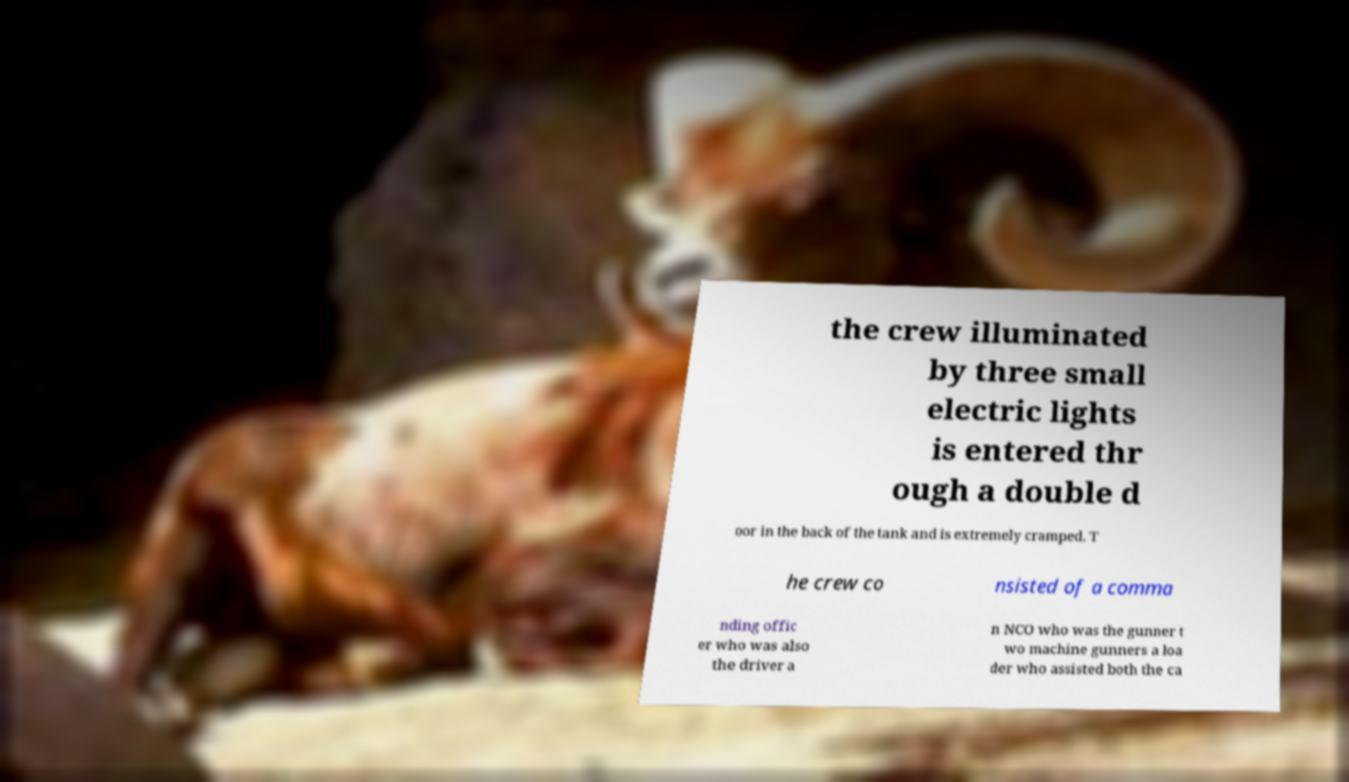For documentation purposes, I need the text within this image transcribed. Could you provide that? the crew illuminated by three small electric lights is entered thr ough a double d oor in the back of the tank and is extremely cramped. T he crew co nsisted of a comma nding offic er who was also the driver a n NCO who was the gunner t wo machine gunners a loa der who assisted both the ca 